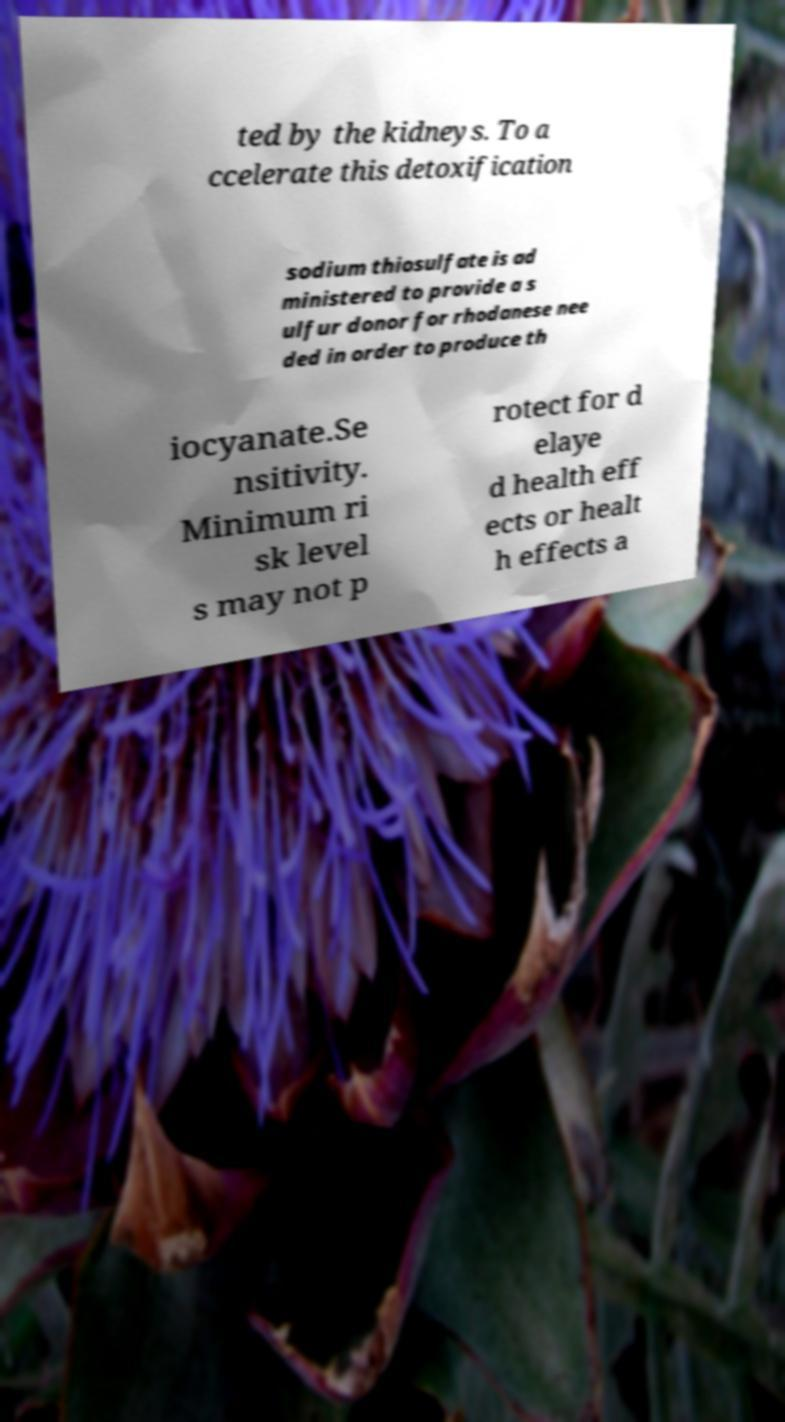I need the written content from this picture converted into text. Can you do that? ted by the kidneys. To a ccelerate this detoxification sodium thiosulfate is ad ministered to provide a s ulfur donor for rhodanese nee ded in order to produce th iocyanate.Se nsitivity. Minimum ri sk level s may not p rotect for d elaye d health eff ects or healt h effects a 